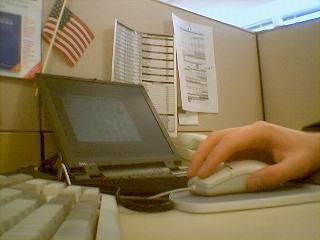How many monitors does this person have on his desk?
Give a very brief answer. 1. How many kites are in the sky?
Give a very brief answer. 0. 